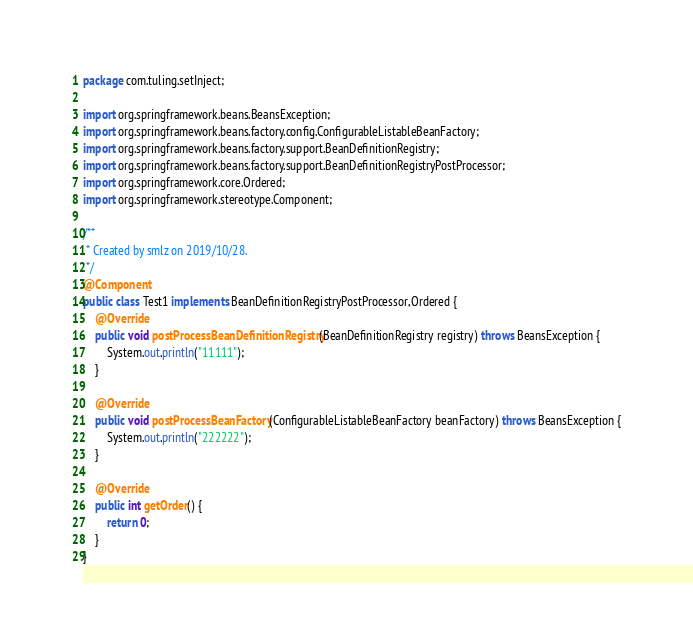Convert code to text. <code><loc_0><loc_0><loc_500><loc_500><_Java_>package com.tuling.setInject;

import org.springframework.beans.BeansException;
import org.springframework.beans.factory.config.ConfigurableListableBeanFactory;
import org.springframework.beans.factory.support.BeanDefinitionRegistry;
import org.springframework.beans.factory.support.BeanDefinitionRegistryPostProcessor;
import org.springframework.core.Ordered;
import org.springframework.stereotype.Component;

/**
 * Created by smlz on 2019/10/28.
 */
@Component
public class Test1 implements BeanDefinitionRegistryPostProcessor,Ordered {
	@Override
	public void postProcessBeanDefinitionRegistry(BeanDefinitionRegistry registry) throws BeansException {
		System.out.println("11111");
	}

	@Override
	public void postProcessBeanFactory(ConfigurableListableBeanFactory beanFactory) throws BeansException {
		System.out.println("222222");
	}

	@Override
	public int getOrder() {
		return 0;
	}
}
</code> 